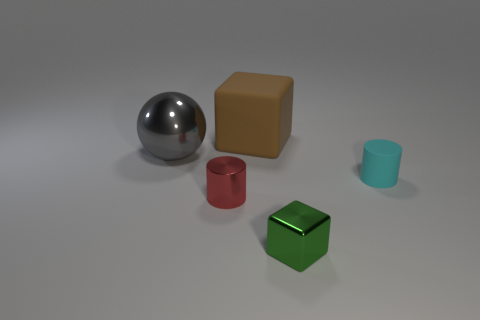The block that is on the left side of the cube that is in front of the brown rubber cube is what color?
Give a very brief answer. Brown. Are there fewer red shiny objects left of the large gray metal thing than red cylinders in front of the green metal cube?
Give a very brief answer. No. How many objects are cubes that are in front of the matte block or large balls?
Make the answer very short. 2. There is a cylinder that is in front of the rubber cylinder; does it have the same size as the large shiny sphere?
Your response must be concise. No. Is the number of tiny red metallic things that are to the left of the tiny metal cylinder less than the number of tiny red metallic objects?
Keep it short and to the point. Yes. What is the material of the green thing that is the same size as the red cylinder?
Offer a terse response. Metal. How many tiny objects are gray matte things or green blocks?
Provide a succinct answer. 1. What number of things are either tiny things to the right of the metallic cylinder or blocks that are in front of the big gray ball?
Provide a succinct answer. 2. Are there fewer small rubber cylinders than tiny matte blocks?
Offer a terse response. No. There is another metallic thing that is the same size as the green metallic thing; what is its shape?
Provide a succinct answer. Cylinder. 